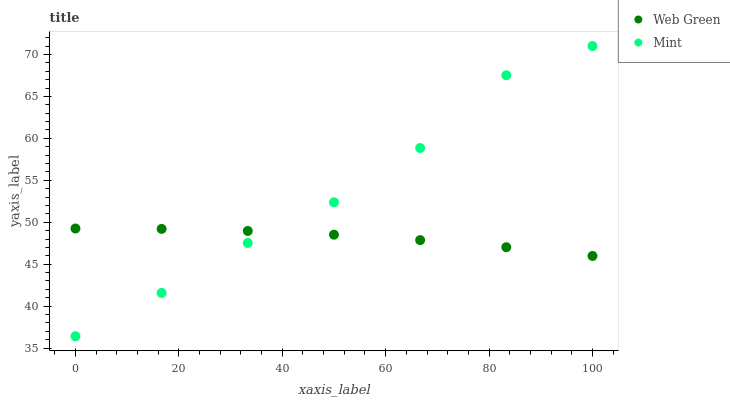Does Web Green have the minimum area under the curve?
Answer yes or no. Yes. Does Mint have the maximum area under the curve?
Answer yes or no. Yes. Does Web Green have the maximum area under the curve?
Answer yes or no. No. Is Web Green the smoothest?
Answer yes or no. Yes. Is Mint the roughest?
Answer yes or no. Yes. Is Web Green the roughest?
Answer yes or no. No. Does Mint have the lowest value?
Answer yes or no. Yes. Does Web Green have the lowest value?
Answer yes or no. No. Does Mint have the highest value?
Answer yes or no. Yes. Does Web Green have the highest value?
Answer yes or no. No. Does Web Green intersect Mint?
Answer yes or no. Yes. Is Web Green less than Mint?
Answer yes or no. No. Is Web Green greater than Mint?
Answer yes or no. No. 